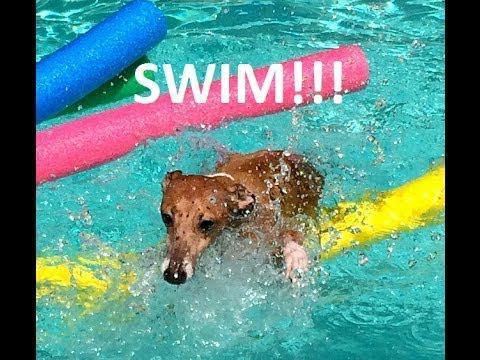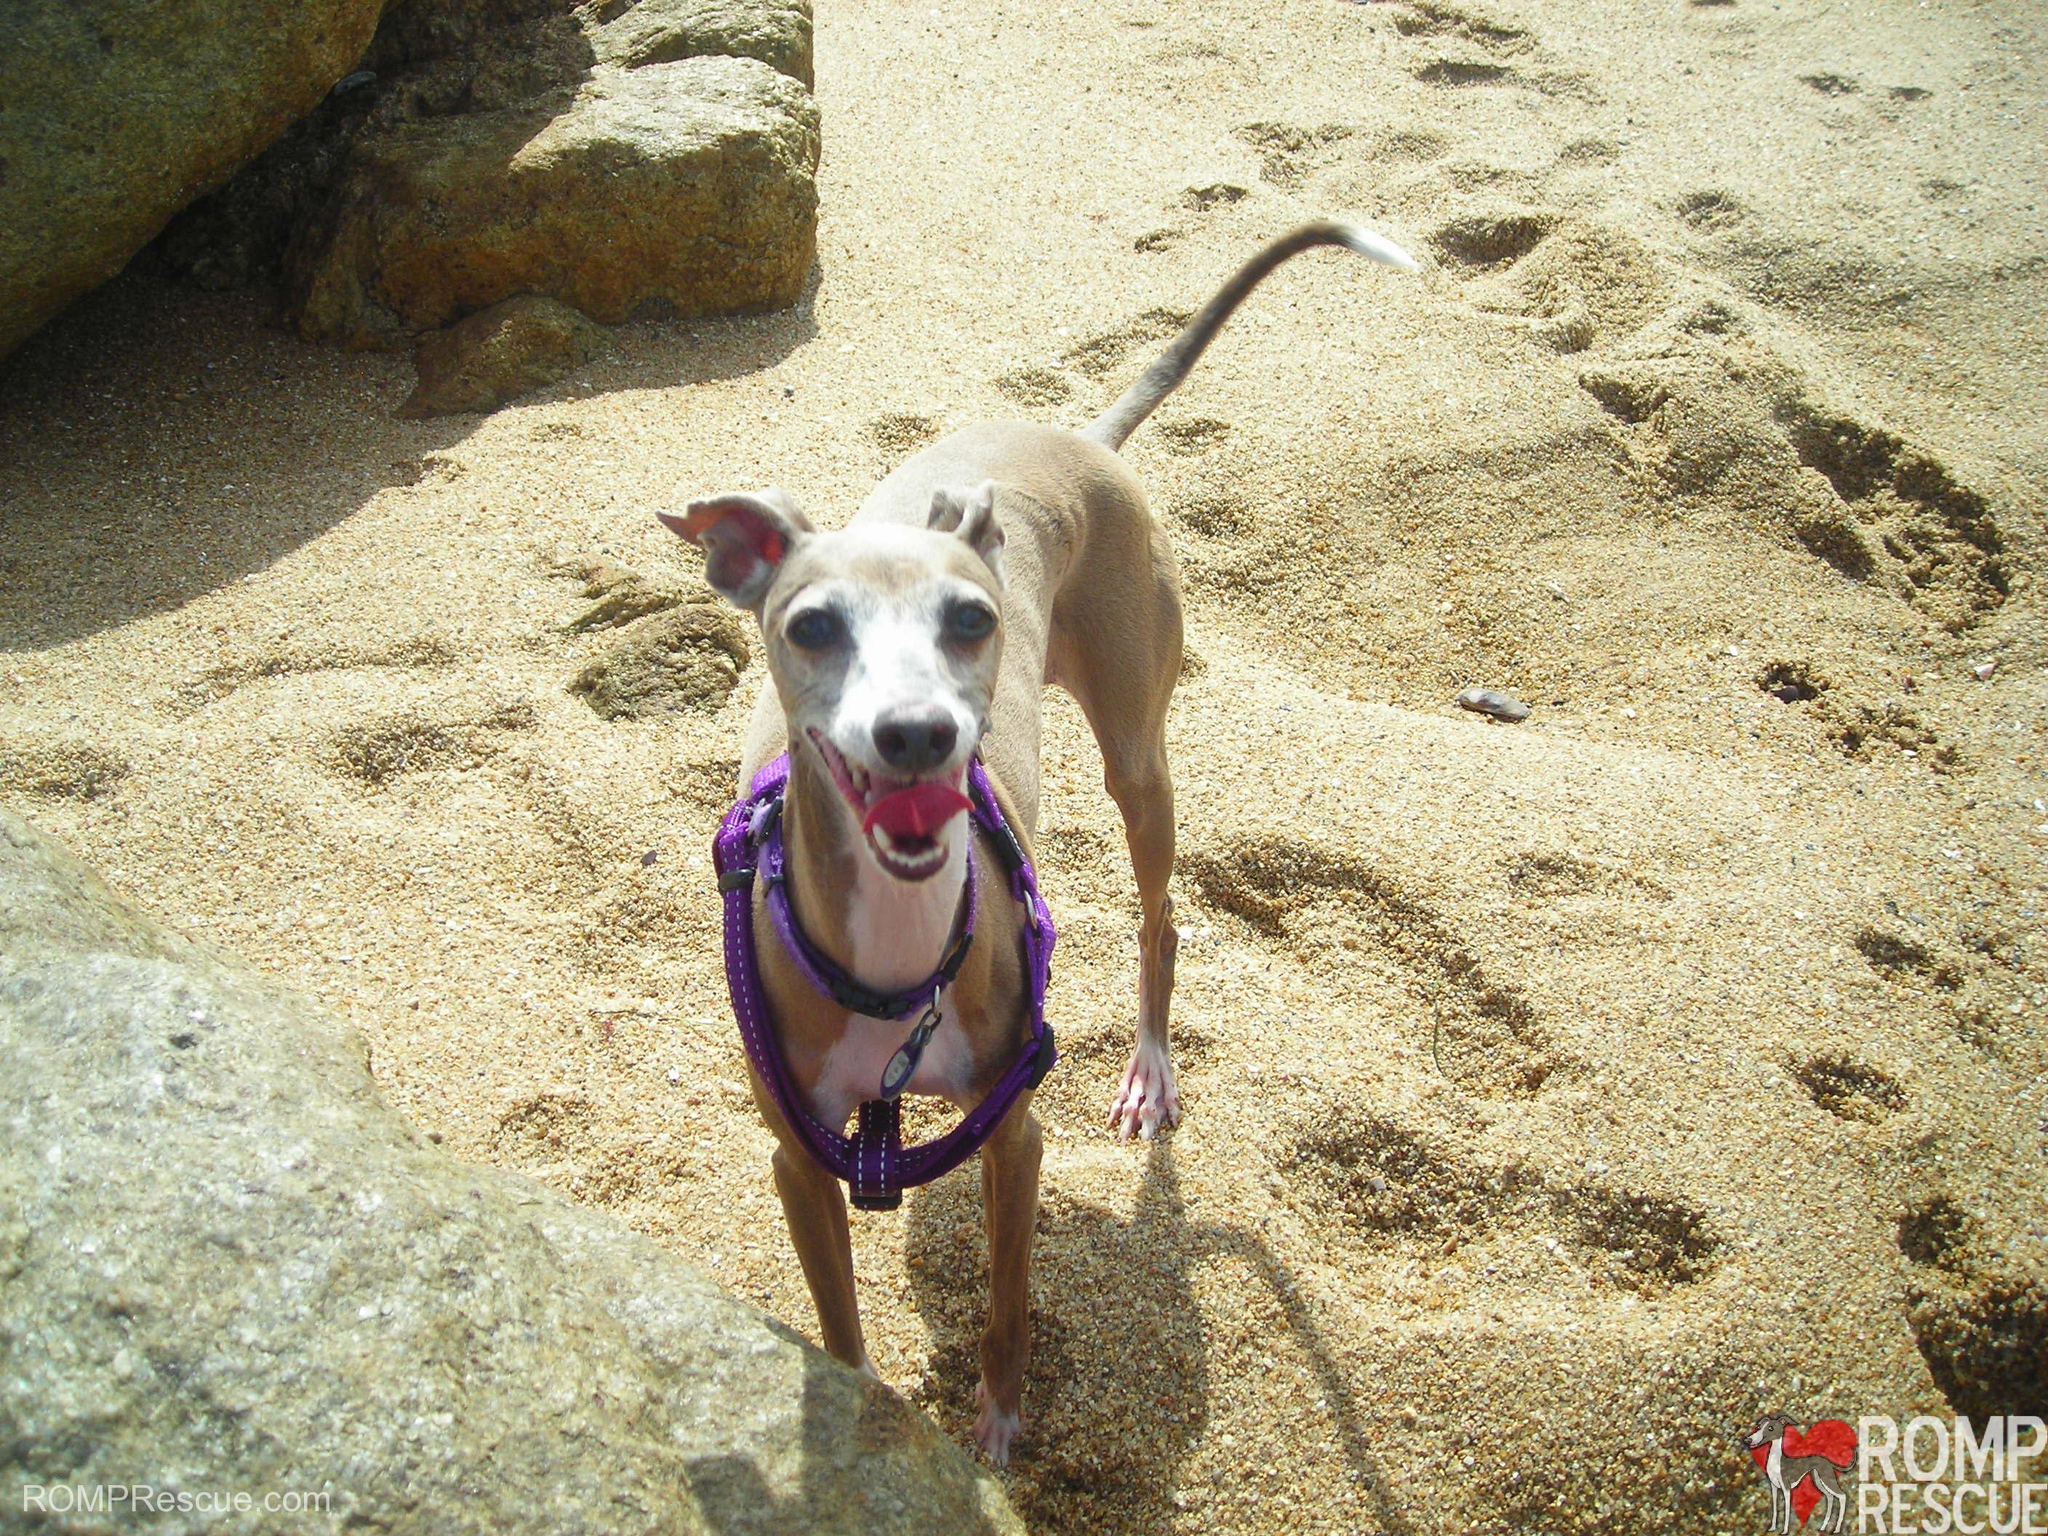The first image is the image on the left, the second image is the image on the right. Given the left and right images, does the statement "At least one dog is standing on land." hold true? Answer yes or no. Yes. 